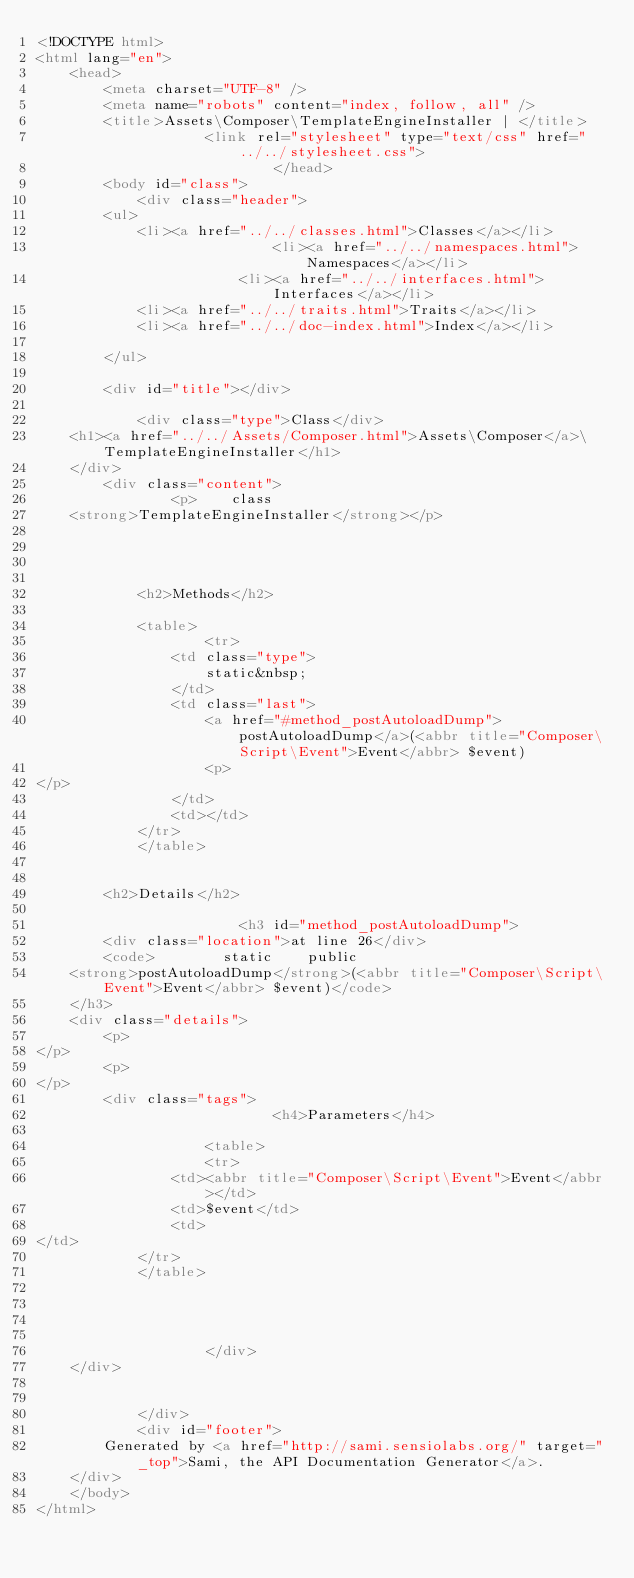<code> <loc_0><loc_0><loc_500><loc_500><_HTML_><!DOCTYPE html>
<html lang="en">
    <head>
        <meta charset="UTF-8" />
        <meta name="robots" content="index, follow, all" />
        <title>Assets\Composer\TemplateEngineInstaller | </title>
                    <link rel="stylesheet" type="text/css" href="../../stylesheet.css">
                            </head>
        <body id="class">
            <div class="header">
        <ul>
            <li><a href="../../classes.html">Classes</a></li>
                            <li><a href="../../namespaces.html">Namespaces</a></li>
                        <li><a href="../../interfaces.html">Interfaces</a></li>
            <li><a href="../../traits.html">Traits</a></li>
            <li><a href="../../doc-index.html">Index</a></li>
            
        </ul>

        <div id="title"></div>

            <div class="type">Class</div>
    <h1><a href="../../Assets/Composer.html">Assets\Composer</a>\TemplateEngineInstaller</h1>
    </div>
        <div class="content">
                <p>    class
    <strong>TemplateEngineInstaller</strong></p>

    
    
    
            <h2>Methods</h2>

            <table>
                    <tr>
                <td class="type">
                    static&nbsp;
                </td>
                <td class="last">
                    <a href="#method_postAutoloadDump">postAutoloadDump</a>(<abbr title="Composer\Script\Event">Event</abbr> $event)
                    <p>
</p>
                </td>
                <td></td>
            </tr>
            </table>


        <h2>Details</h2>

                        <h3 id="method_postAutoloadDump">
        <div class="location">at line 26</div>
        <code>        static    public            
    <strong>postAutoloadDump</strong>(<abbr title="Composer\Script\Event">Event</abbr> $event)</code>
    </h3>
    <div class="details">
        <p>
</p>
        <p>
</p>
        <div class="tags">
                            <h4>Parameters</h4>

                    <table>
                    <tr>
                <td><abbr title="Composer\Script\Event">Event</abbr></td>
                <td>$event</td>
                <td>
</td>
            </tr>
            </table>

            
            
            
                    </div>
    </div>

    
            </div>
            <div id="footer">
        Generated by <a href="http://sami.sensiolabs.org/" target="_top">Sami, the API Documentation Generator</a>.
    </div>
    </body>
</html>
</code> 